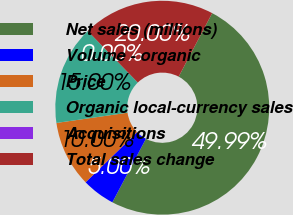Convert chart to OTSL. <chart><loc_0><loc_0><loc_500><loc_500><pie_chart><fcel>Net sales (millions)<fcel>Volume - organic<fcel>Price<fcel>Organic local-currency sales<fcel>Acquisitions<fcel>Total sales change<nl><fcel>49.99%<fcel>5.0%<fcel>10.0%<fcel>15.0%<fcel>0.0%<fcel>20.0%<nl></chart> 